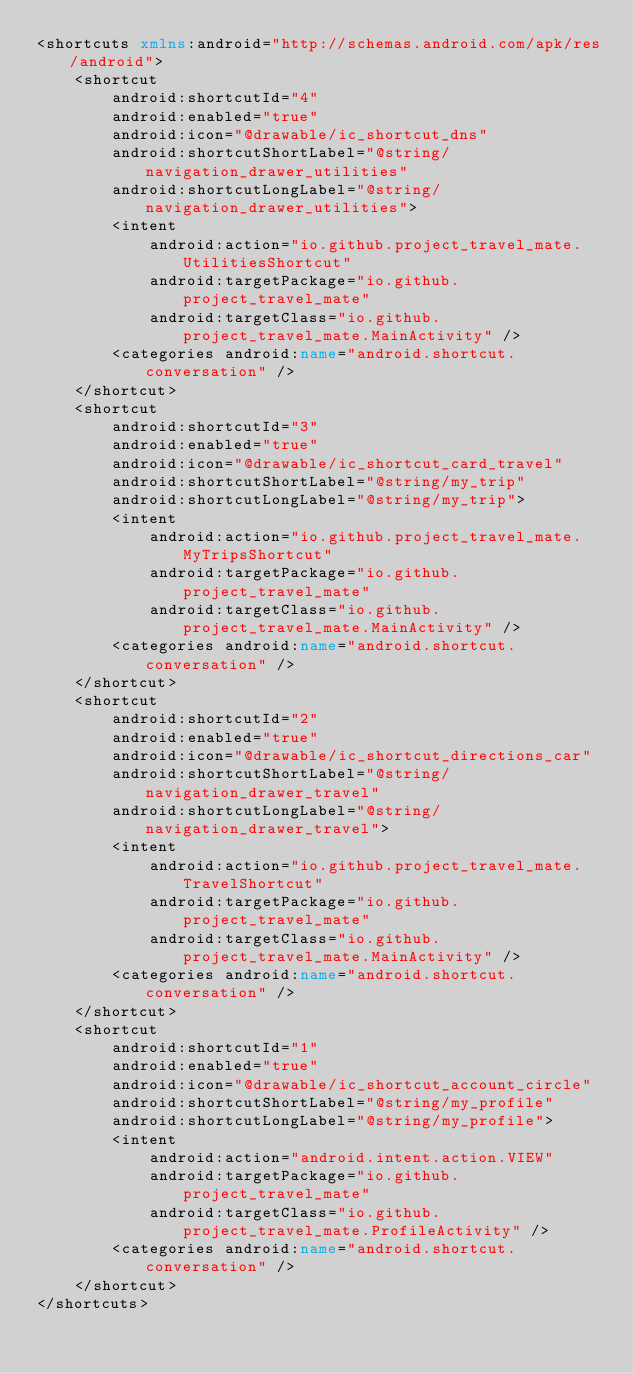Convert code to text. <code><loc_0><loc_0><loc_500><loc_500><_XML_><shortcuts xmlns:android="http://schemas.android.com/apk/res/android">
    <shortcut
        android:shortcutId="4"
        android:enabled="true"
        android:icon="@drawable/ic_shortcut_dns"
        android:shortcutShortLabel="@string/navigation_drawer_utilities"
        android:shortcutLongLabel="@string/navigation_drawer_utilities">
        <intent
            android:action="io.github.project_travel_mate.UtilitiesShortcut"
            android:targetPackage="io.github.project_travel_mate"
            android:targetClass="io.github.project_travel_mate.MainActivity" />
        <categories android:name="android.shortcut.conversation" />
    </shortcut>
    <shortcut
        android:shortcutId="3"
        android:enabled="true"
        android:icon="@drawable/ic_shortcut_card_travel"
        android:shortcutShortLabel="@string/my_trip"
        android:shortcutLongLabel="@string/my_trip">
        <intent
            android:action="io.github.project_travel_mate.MyTripsShortcut"
            android:targetPackage="io.github.project_travel_mate"
            android:targetClass="io.github.project_travel_mate.MainActivity" />
        <categories android:name="android.shortcut.conversation" />
    </shortcut>
    <shortcut
        android:shortcutId="2"
        android:enabled="true"
        android:icon="@drawable/ic_shortcut_directions_car"
        android:shortcutShortLabel="@string/navigation_drawer_travel"
        android:shortcutLongLabel="@string/navigation_drawer_travel">
        <intent
            android:action="io.github.project_travel_mate.TravelShortcut"
            android:targetPackage="io.github.project_travel_mate"
            android:targetClass="io.github.project_travel_mate.MainActivity" />
        <categories android:name="android.shortcut.conversation" />
    </shortcut>
    <shortcut
        android:shortcutId="1"
        android:enabled="true"
        android:icon="@drawable/ic_shortcut_account_circle"
        android:shortcutShortLabel="@string/my_profile"
        android:shortcutLongLabel="@string/my_profile">
        <intent
            android:action="android.intent.action.VIEW"
            android:targetPackage="io.github.project_travel_mate"
            android:targetClass="io.github.project_travel_mate.ProfileActivity" />
        <categories android:name="android.shortcut.conversation" />
    </shortcut>
</shortcuts></code> 